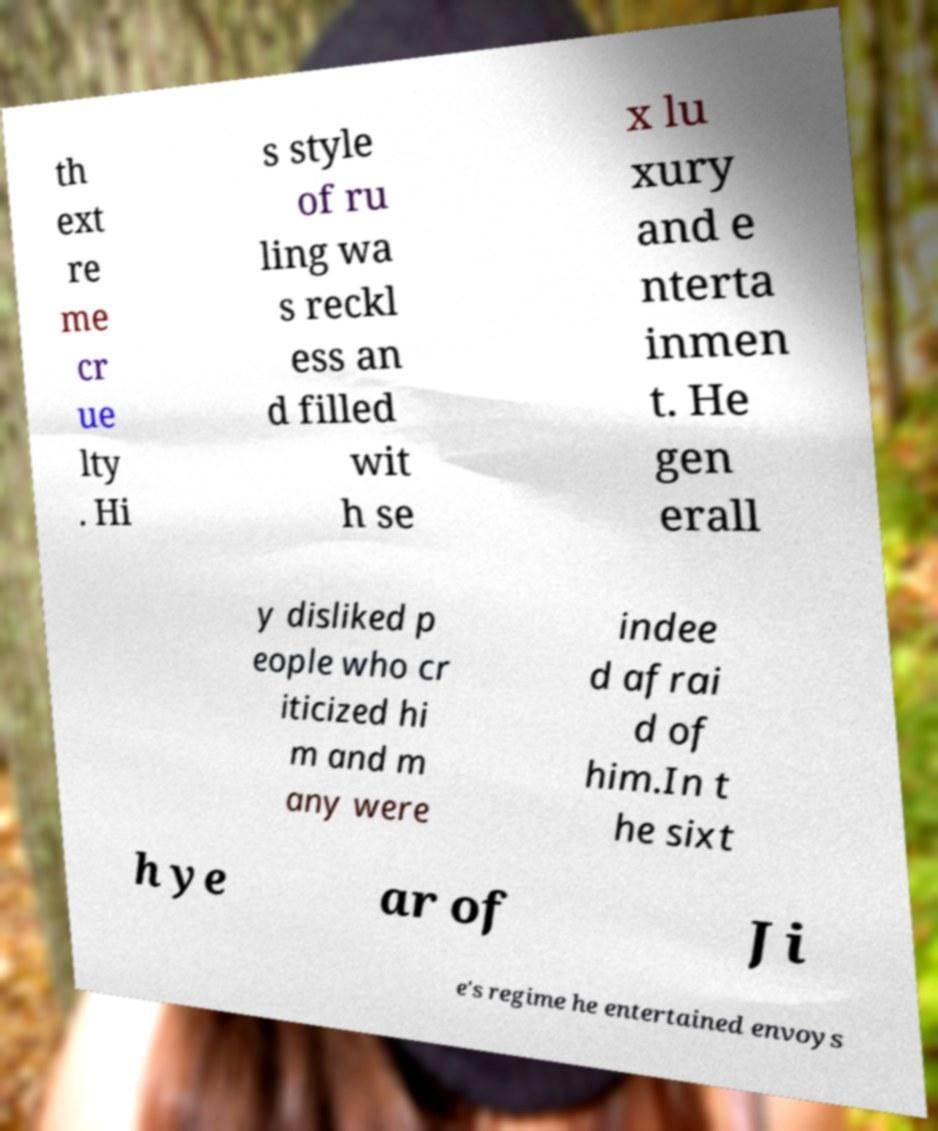Could you assist in decoding the text presented in this image and type it out clearly? th ext re me cr ue lty . Hi s style of ru ling wa s reckl ess an d filled wit h se x lu xury and e nterta inmen t. He gen erall y disliked p eople who cr iticized hi m and m any were indee d afrai d of him.In t he sixt h ye ar of Ji e's regime he entertained envoys 